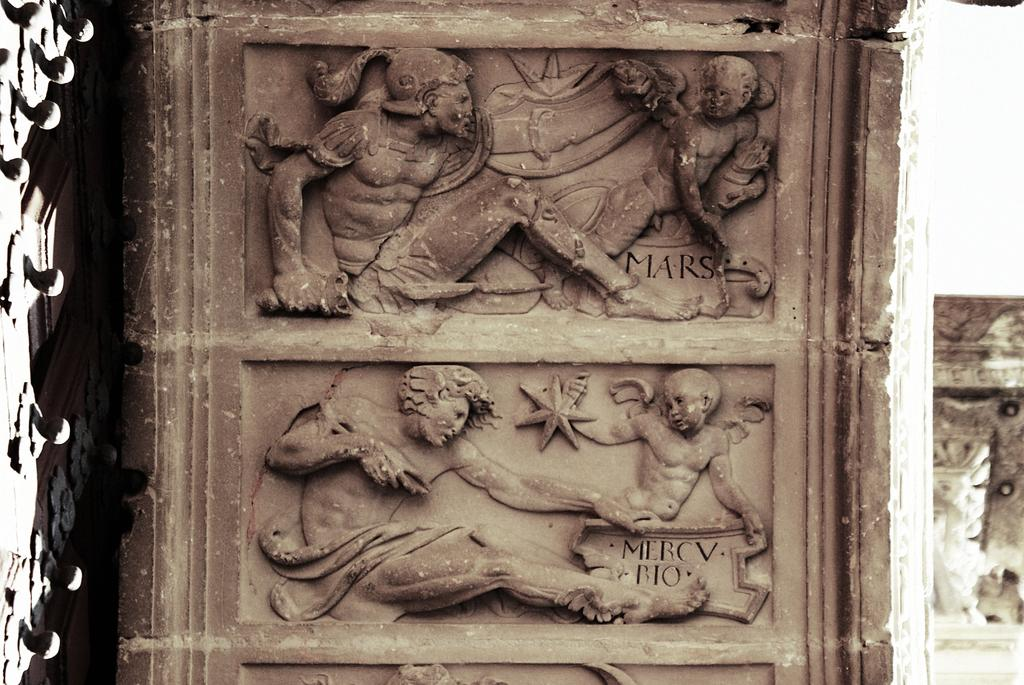What type of artwork is present on the wall in the image? There are sculptures on the wall in the image. What type of tent is visible in the image? There is no tent present in the image; it features sculptures on the wall. Is the father depicted in any of the sculptures in the image? The provided facts do not mention any specific subjects or themes within the sculptures, so it is impossible to determine if a father is depicted. 